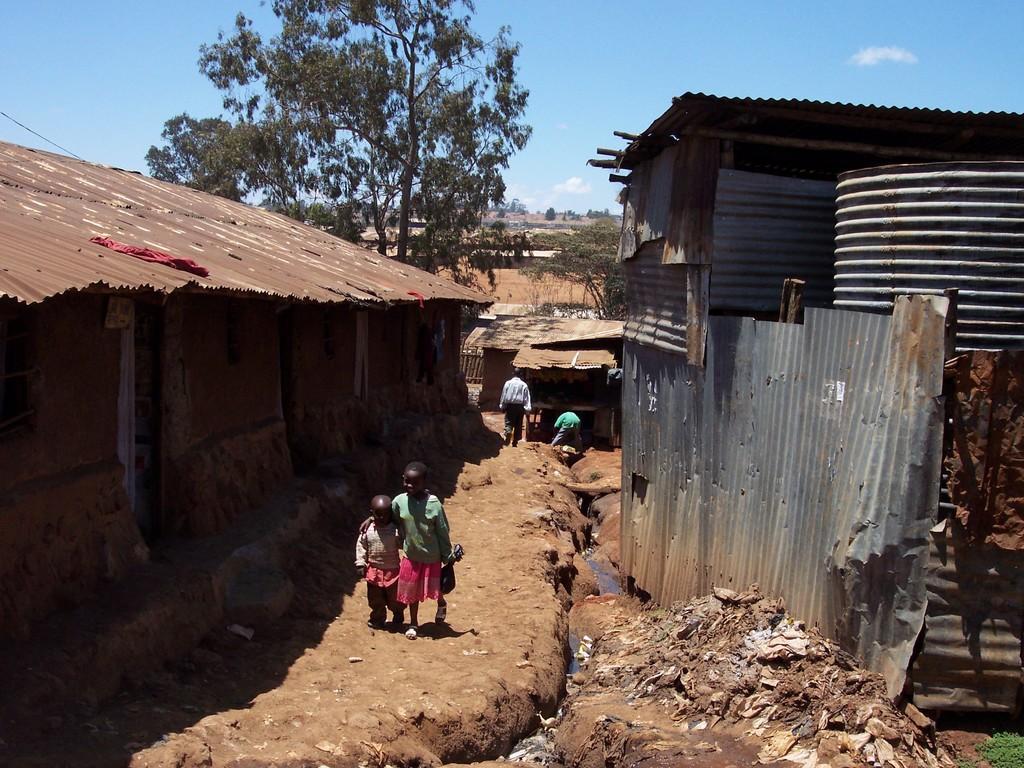How would you summarize this image in a sentence or two? In this image I can see in the middle two children are walking, there are iron sheds on either side. At the back side there are trees, at the top it is the cloudy sky. 